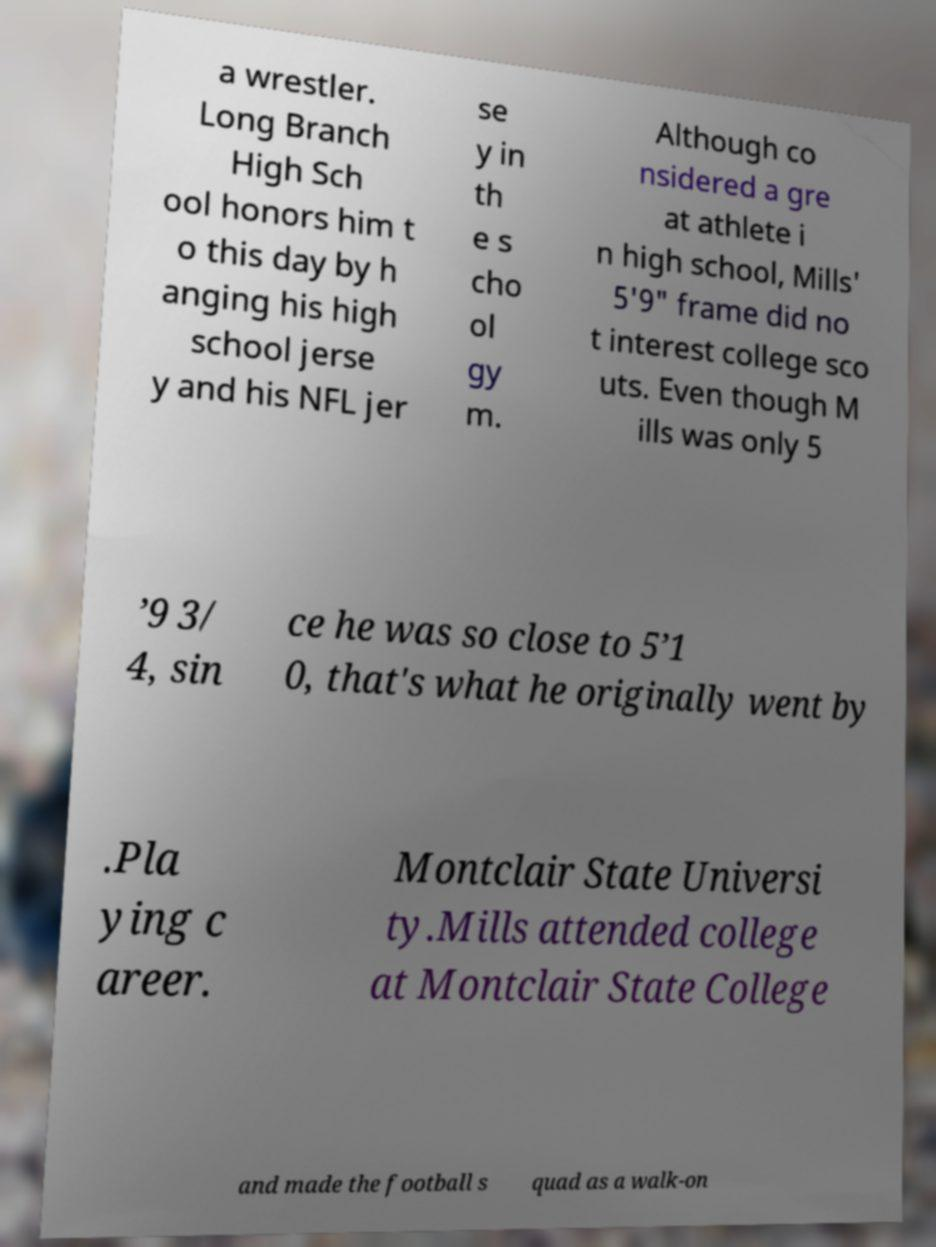Please read and relay the text visible in this image. What does it say? a wrestler. Long Branch High Sch ool honors him t o this day by h anging his high school jerse y and his NFL jer se y in th e s cho ol gy m. Although co nsidered a gre at athlete i n high school, Mills' 5'9" frame did no t interest college sco uts. Even though M ills was only 5 ’9 3/ 4, sin ce he was so close to 5’1 0, that's what he originally went by .Pla ying c areer. Montclair State Universi ty.Mills attended college at Montclair State College and made the football s quad as a walk-on 